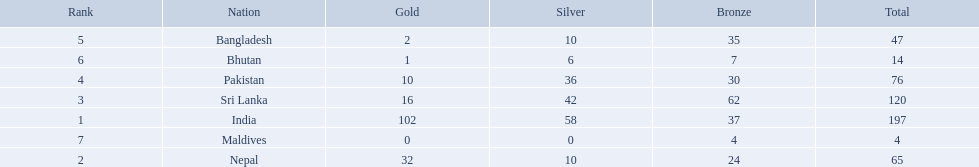What are all the countries listed in the table? India, Nepal, Sri Lanka, Pakistan, Bangladesh, Bhutan, Maldives. Which of these is not india? Nepal, Sri Lanka, Pakistan, Bangladesh, Bhutan, Maldives. Of these, which is first? Nepal. 